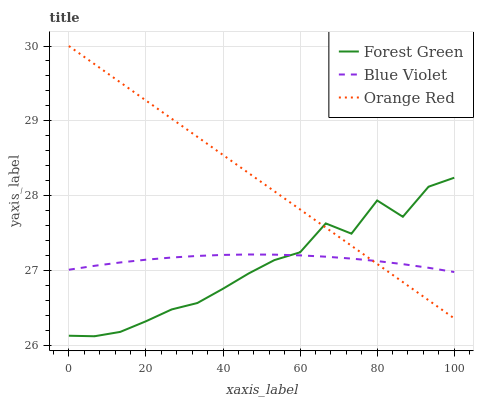Does Forest Green have the minimum area under the curve?
Answer yes or no. Yes. Does Orange Red have the maximum area under the curve?
Answer yes or no. Yes. Does Blue Violet have the minimum area under the curve?
Answer yes or no. No. Does Blue Violet have the maximum area under the curve?
Answer yes or no. No. Is Orange Red the smoothest?
Answer yes or no. Yes. Is Forest Green the roughest?
Answer yes or no. Yes. Is Blue Violet the smoothest?
Answer yes or no. No. Is Blue Violet the roughest?
Answer yes or no. No. Does Orange Red have the lowest value?
Answer yes or no. No. Does Blue Violet have the highest value?
Answer yes or no. No. 